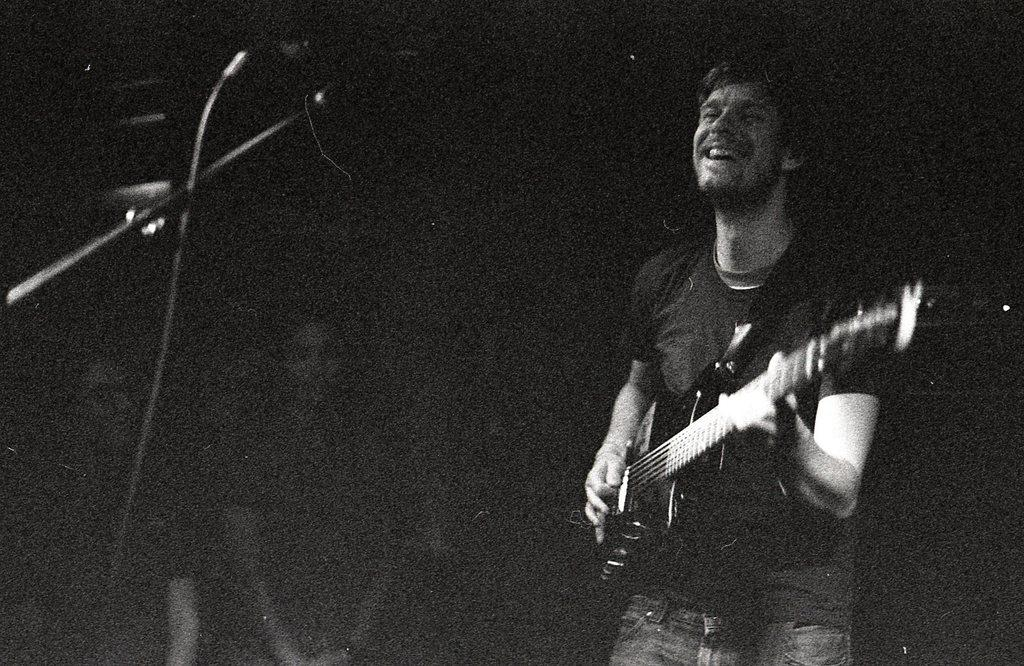What is the man in the image doing? The man is playing the guitar and singing on a microphone. What instrument is the man holding in the image? The man is holding a guitar in the image. Can you describe the background of the image? The background of the image is dark. Are there any other people present in the image? Yes, there are people in the background of the image. What type of table is the man using to make his payment for the performance? There is no table or payment mentioned in the image; the man is simply playing the guitar and singing on a microphone. 